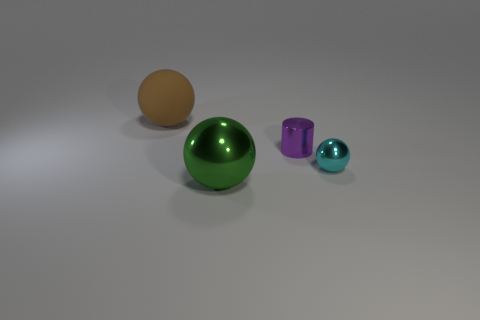What shape is the large object on the right side of the large brown thing that is to the left of the purple cylinder?
Give a very brief answer. Sphere. Are there any other things that have the same material as the brown thing?
Ensure brevity in your answer.  No. What is the shape of the purple object?
Your answer should be compact. Cylinder. There is a sphere that is on the right side of the big thing that is in front of the big rubber object; what is its size?
Offer a terse response. Small. Are there an equal number of large objects in front of the green ball and small spheres right of the matte ball?
Keep it short and to the point. No. What is the sphere that is both behind the big metallic ball and left of the cyan thing made of?
Provide a short and direct response. Rubber. Is the size of the cyan object the same as the green shiny object in front of the purple thing?
Your answer should be very brief. No. Is the number of small cyan objects in front of the rubber sphere greater than the number of tiny green shiny blocks?
Give a very brief answer. Yes. There is a large thing behind the big ball in front of the thing that is left of the green metal sphere; what is its color?
Give a very brief answer. Brown. Are the cylinder and the cyan thing made of the same material?
Offer a terse response. Yes. 